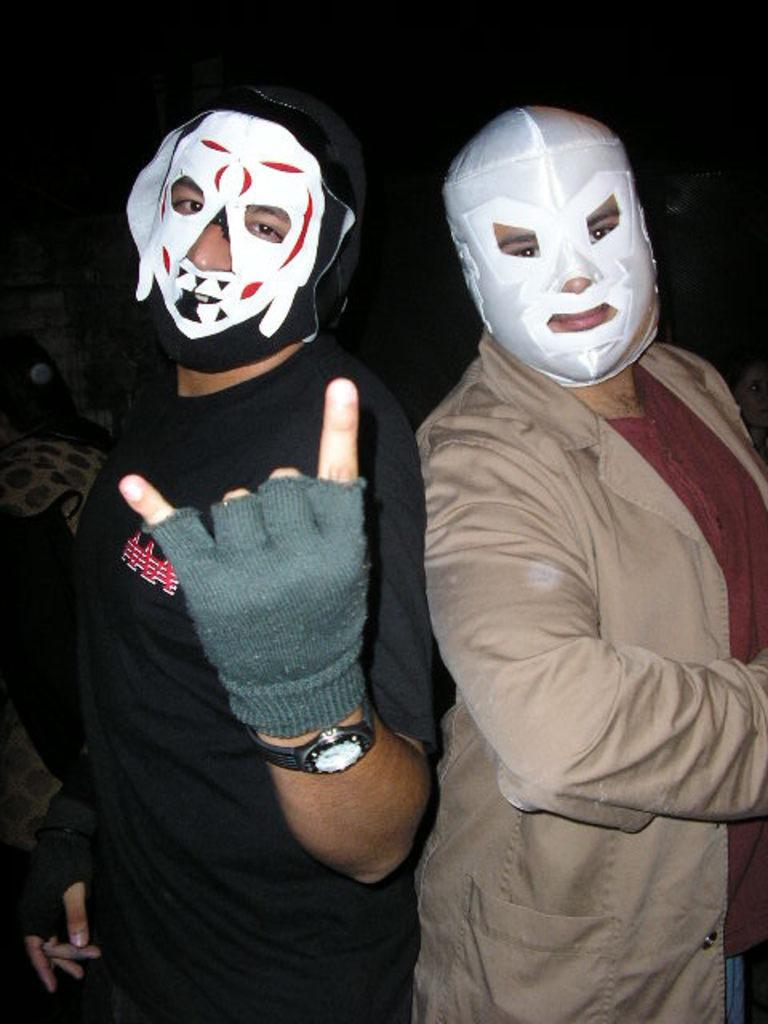How many people are in the image? There are two persons in the image. What are the persons wearing on their faces? Both persons are wearing face masks. What additional protective gear is the person on the left side wearing? The person on the left side is also wearing gloves. What can be observed about the background of the image? The background of the image is dark. What type of juice is the person on the right side drinking in the image? There is no juice present in the image, and the person on the right side is not shown drinking anything. 